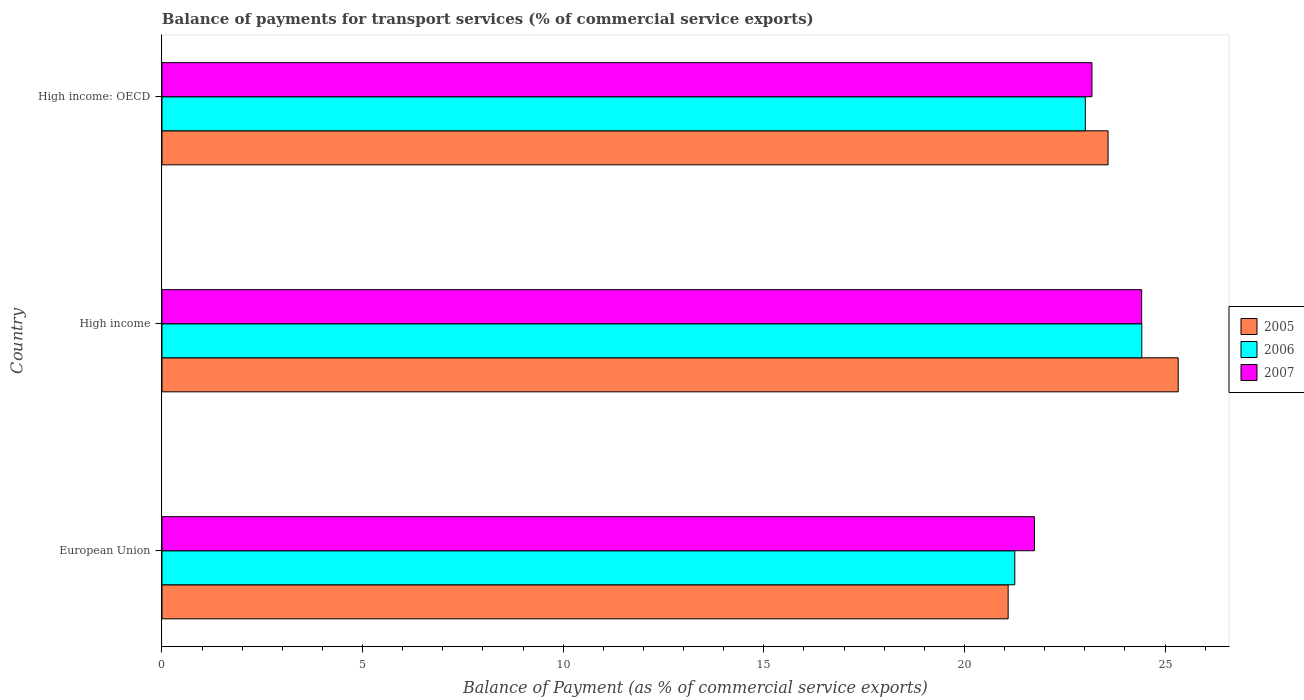Are the number of bars on each tick of the Y-axis equal?
Provide a short and direct response. Yes. What is the balance of payments for transport services in 2005 in High income?
Keep it short and to the point. 25.33. Across all countries, what is the maximum balance of payments for transport services in 2007?
Your answer should be very brief. 24.42. Across all countries, what is the minimum balance of payments for transport services in 2005?
Ensure brevity in your answer.  21.09. In which country was the balance of payments for transport services in 2006 maximum?
Make the answer very short. High income. In which country was the balance of payments for transport services in 2007 minimum?
Offer a terse response. European Union. What is the total balance of payments for transport services in 2006 in the graph?
Offer a very short reply. 68.69. What is the difference between the balance of payments for transport services in 2006 in European Union and that in High income?
Give a very brief answer. -3.17. What is the difference between the balance of payments for transport services in 2006 in High income: OECD and the balance of payments for transport services in 2007 in High income?
Your response must be concise. -1.4. What is the average balance of payments for transport services in 2005 per country?
Your answer should be very brief. 23.33. What is the difference between the balance of payments for transport services in 2007 and balance of payments for transport services in 2006 in High income: OECD?
Provide a short and direct response. 0.17. In how many countries, is the balance of payments for transport services in 2006 greater than 23 %?
Make the answer very short. 2. What is the ratio of the balance of payments for transport services in 2006 in European Union to that in High income: OECD?
Your answer should be compact. 0.92. Is the balance of payments for transport services in 2007 in European Union less than that in High income: OECD?
Your answer should be compact. Yes. Is the difference between the balance of payments for transport services in 2007 in European Union and High income: OECD greater than the difference between the balance of payments for transport services in 2006 in European Union and High income: OECD?
Provide a succinct answer. Yes. What is the difference between the highest and the second highest balance of payments for transport services in 2007?
Ensure brevity in your answer.  1.24. What is the difference between the highest and the lowest balance of payments for transport services in 2006?
Provide a succinct answer. 3.17. What does the 3rd bar from the top in High income: OECD represents?
Ensure brevity in your answer.  2005. Is it the case that in every country, the sum of the balance of payments for transport services in 2005 and balance of payments for transport services in 2006 is greater than the balance of payments for transport services in 2007?
Provide a succinct answer. Yes. Are all the bars in the graph horizontal?
Give a very brief answer. Yes. Where does the legend appear in the graph?
Provide a succinct answer. Center right. How many legend labels are there?
Make the answer very short. 3. What is the title of the graph?
Your response must be concise. Balance of payments for transport services (% of commercial service exports). What is the label or title of the X-axis?
Your answer should be compact. Balance of Payment (as % of commercial service exports). What is the label or title of the Y-axis?
Ensure brevity in your answer.  Country. What is the Balance of Payment (as % of commercial service exports) in 2005 in European Union?
Your response must be concise. 21.09. What is the Balance of Payment (as % of commercial service exports) of 2006 in European Union?
Offer a very short reply. 21.25. What is the Balance of Payment (as % of commercial service exports) of 2007 in European Union?
Provide a succinct answer. 21.74. What is the Balance of Payment (as % of commercial service exports) in 2005 in High income?
Keep it short and to the point. 25.33. What is the Balance of Payment (as % of commercial service exports) in 2006 in High income?
Keep it short and to the point. 24.42. What is the Balance of Payment (as % of commercial service exports) in 2007 in High income?
Keep it short and to the point. 24.42. What is the Balance of Payment (as % of commercial service exports) in 2005 in High income: OECD?
Offer a terse response. 23.58. What is the Balance of Payment (as % of commercial service exports) of 2006 in High income: OECD?
Provide a succinct answer. 23.01. What is the Balance of Payment (as % of commercial service exports) of 2007 in High income: OECD?
Keep it short and to the point. 23.18. Across all countries, what is the maximum Balance of Payment (as % of commercial service exports) of 2005?
Ensure brevity in your answer.  25.33. Across all countries, what is the maximum Balance of Payment (as % of commercial service exports) in 2006?
Give a very brief answer. 24.42. Across all countries, what is the maximum Balance of Payment (as % of commercial service exports) in 2007?
Make the answer very short. 24.42. Across all countries, what is the minimum Balance of Payment (as % of commercial service exports) of 2005?
Your response must be concise. 21.09. Across all countries, what is the minimum Balance of Payment (as % of commercial service exports) in 2006?
Your answer should be very brief. 21.25. Across all countries, what is the minimum Balance of Payment (as % of commercial service exports) of 2007?
Give a very brief answer. 21.74. What is the total Balance of Payment (as % of commercial service exports) of 2005 in the graph?
Your answer should be compact. 69.99. What is the total Balance of Payment (as % of commercial service exports) of 2006 in the graph?
Your answer should be very brief. 68.69. What is the total Balance of Payment (as % of commercial service exports) of 2007 in the graph?
Your response must be concise. 69.34. What is the difference between the Balance of Payment (as % of commercial service exports) in 2005 in European Union and that in High income?
Ensure brevity in your answer.  -4.24. What is the difference between the Balance of Payment (as % of commercial service exports) of 2006 in European Union and that in High income?
Give a very brief answer. -3.17. What is the difference between the Balance of Payment (as % of commercial service exports) in 2007 in European Union and that in High income?
Your answer should be compact. -2.67. What is the difference between the Balance of Payment (as % of commercial service exports) in 2005 in European Union and that in High income: OECD?
Provide a short and direct response. -2.49. What is the difference between the Balance of Payment (as % of commercial service exports) in 2006 in European Union and that in High income: OECD?
Offer a very short reply. -1.76. What is the difference between the Balance of Payment (as % of commercial service exports) of 2007 in European Union and that in High income: OECD?
Keep it short and to the point. -1.43. What is the difference between the Balance of Payment (as % of commercial service exports) of 2005 in High income and that in High income: OECD?
Your answer should be compact. 1.75. What is the difference between the Balance of Payment (as % of commercial service exports) in 2006 in High income and that in High income: OECD?
Your response must be concise. 1.41. What is the difference between the Balance of Payment (as % of commercial service exports) in 2007 in High income and that in High income: OECD?
Offer a very short reply. 1.24. What is the difference between the Balance of Payment (as % of commercial service exports) in 2005 in European Union and the Balance of Payment (as % of commercial service exports) in 2006 in High income?
Offer a terse response. -3.33. What is the difference between the Balance of Payment (as % of commercial service exports) in 2005 in European Union and the Balance of Payment (as % of commercial service exports) in 2007 in High income?
Your answer should be very brief. -3.33. What is the difference between the Balance of Payment (as % of commercial service exports) in 2006 in European Union and the Balance of Payment (as % of commercial service exports) in 2007 in High income?
Keep it short and to the point. -3.16. What is the difference between the Balance of Payment (as % of commercial service exports) in 2005 in European Union and the Balance of Payment (as % of commercial service exports) in 2006 in High income: OECD?
Provide a succinct answer. -1.92. What is the difference between the Balance of Payment (as % of commercial service exports) of 2005 in European Union and the Balance of Payment (as % of commercial service exports) of 2007 in High income: OECD?
Provide a short and direct response. -2.09. What is the difference between the Balance of Payment (as % of commercial service exports) in 2006 in European Union and the Balance of Payment (as % of commercial service exports) in 2007 in High income: OECD?
Your answer should be very brief. -1.92. What is the difference between the Balance of Payment (as % of commercial service exports) in 2005 in High income and the Balance of Payment (as % of commercial service exports) in 2006 in High income: OECD?
Your answer should be very brief. 2.31. What is the difference between the Balance of Payment (as % of commercial service exports) in 2005 in High income and the Balance of Payment (as % of commercial service exports) in 2007 in High income: OECD?
Your answer should be very brief. 2.15. What is the difference between the Balance of Payment (as % of commercial service exports) of 2006 in High income and the Balance of Payment (as % of commercial service exports) of 2007 in High income: OECD?
Provide a short and direct response. 1.24. What is the average Balance of Payment (as % of commercial service exports) in 2005 per country?
Your response must be concise. 23.33. What is the average Balance of Payment (as % of commercial service exports) of 2006 per country?
Make the answer very short. 22.9. What is the average Balance of Payment (as % of commercial service exports) of 2007 per country?
Offer a terse response. 23.11. What is the difference between the Balance of Payment (as % of commercial service exports) of 2005 and Balance of Payment (as % of commercial service exports) of 2006 in European Union?
Provide a short and direct response. -0.17. What is the difference between the Balance of Payment (as % of commercial service exports) of 2005 and Balance of Payment (as % of commercial service exports) of 2007 in European Union?
Offer a very short reply. -0.66. What is the difference between the Balance of Payment (as % of commercial service exports) of 2006 and Balance of Payment (as % of commercial service exports) of 2007 in European Union?
Give a very brief answer. -0.49. What is the difference between the Balance of Payment (as % of commercial service exports) of 2005 and Balance of Payment (as % of commercial service exports) of 2006 in High income?
Provide a succinct answer. 0.91. What is the difference between the Balance of Payment (as % of commercial service exports) of 2005 and Balance of Payment (as % of commercial service exports) of 2007 in High income?
Your answer should be compact. 0.91. What is the difference between the Balance of Payment (as % of commercial service exports) of 2006 and Balance of Payment (as % of commercial service exports) of 2007 in High income?
Offer a terse response. 0. What is the difference between the Balance of Payment (as % of commercial service exports) of 2005 and Balance of Payment (as % of commercial service exports) of 2006 in High income: OECD?
Provide a succinct answer. 0.57. What is the difference between the Balance of Payment (as % of commercial service exports) in 2005 and Balance of Payment (as % of commercial service exports) in 2007 in High income: OECD?
Offer a very short reply. 0.4. What is the difference between the Balance of Payment (as % of commercial service exports) in 2006 and Balance of Payment (as % of commercial service exports) in 2007 in High income: OECD?
Make the answer very short. -0.17. What is the ratio of the Balance of Payment (as % of commercial service exports) in 2005 in European Union to that in High income?
Give a very brief answer. 0.83. What is the ratio of the Balance of Payment (as % of commercial service exports) of 2006 in European Union to that in High income?
Your answer should be compact. 0.87. What is the ratio of the Balance of Payment (as % of commercial service exports) in 2007 in European Union to that in High income?
Your answer should be compact. 0.89. What is the ratio of the Balance of Payment (as % of commercial service exports) in 2005 in European Union to that in High income: OECD?
Make the answer very short. 0.89. What is the ratio of the Balance of Payment (as % of commercial service exports) of 2006 in European Union to that in High income: OECD?
Make the answer very short. 0.92. What is the ratio of the Balance of Payment (as % of commercial service exports) of 2007 in European Union to that in High income: OECD?
Your answer should be very brief. 0.94. What is the ratio of the Balance of Payment (as % of commercial service exports) in 2005 in High income to that in High income: OECD?
Ensure brevity in your answer.  1.07. What is the ratio of the Balance of Payment (as % of commercial service exports) in 2006 in High income to that in High income: OECD?
Ensure brevity in your answer.  1.06. What is the ratio of the Balance of Payment (as % of commercial service exports) of 2007 in High income to that in High income: OECD?
Provide a short and direct response. 1.05. What is the difference between the highest and the second highest Balance of Payment (as % of commercial service exports) of 2005?
Offer a very short reply. 1.75. What is the difference between the highest and the second highest Balance of Payment (as % of commercial service exports) of 2006?
Offer a very short reply. 1.41. What is the difference between the highest and the second highest Balance of Payment (as % of commercial service exports) in 2007?
Ensure brevity in your answer.  1.24. What is the difference between the highest and the lowest Balance of Payment (as % of commercial service exports) of 2005?
Keep it short and to the point. 4.24. What is the difference between the highest and the lowest Balance of Payment (as % of commercial service exports) in 2006?
Provide a succinct answer. 3.17. What is the difference between the highest and the lowest Balance of Payment (as % of commercial service exports) in 2007?
Keep it short and to the point. 2.67. 